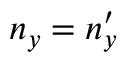Convert formula to latex. <formula><loc_0><loc_0><loc_500><loc_500>n _ { y } = n _ { y } ^ { \prime }</formula> 